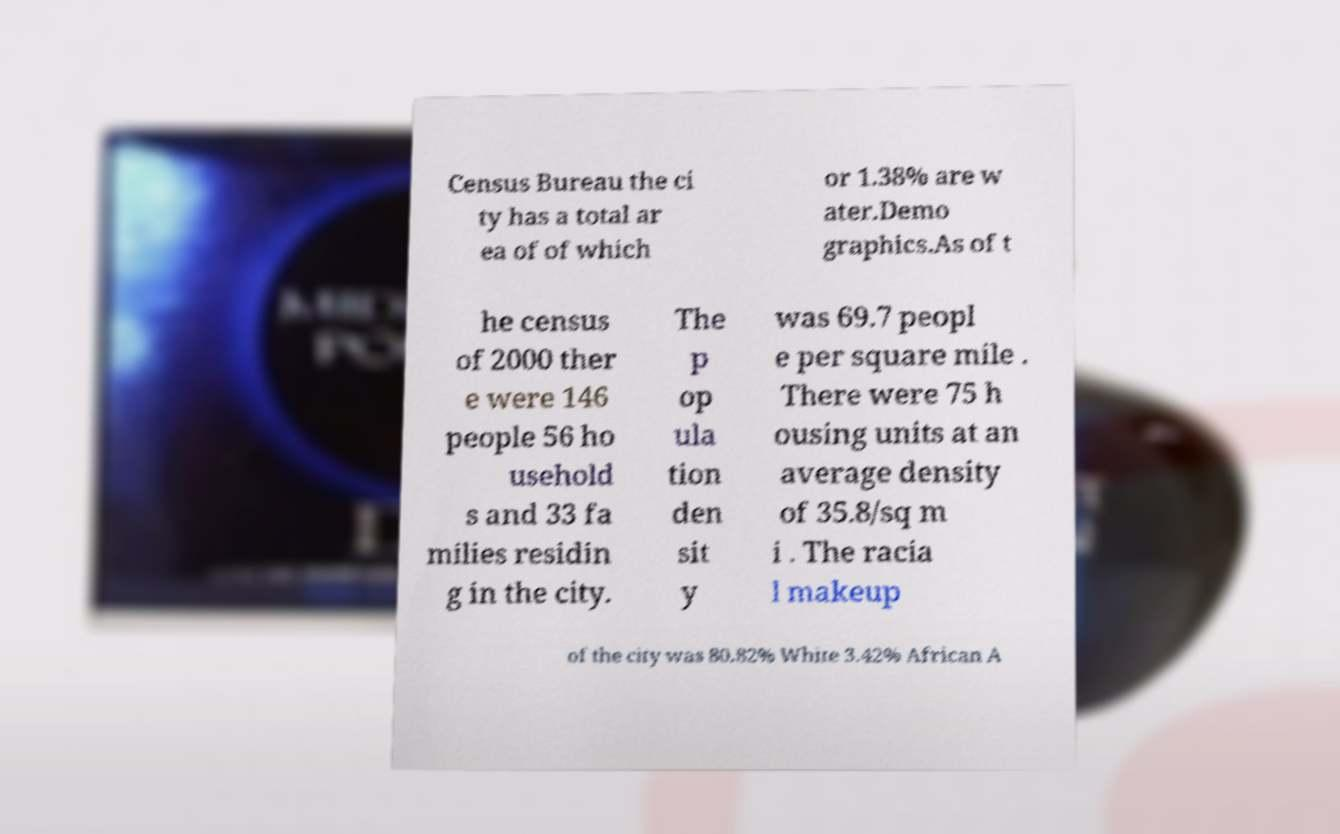Can you read and provide the text displayed in the image?This photo seems to have some interesting text. Can you extract and type it out for me? Census Bureau the ci ty has a total ar ea of of which or 1.38% are w ater.Demo graphics.As of t he census of 2000 ther e were 146 people 56 ho usehold s and 33 fa milies residin g in the city. The p op ula tion den sit y was 69.7 peopl e per square mile . There were 75 h ousing units at an average density of 35.8/sq m i . The racia l makeup of the city was 80.82% White 3.42% African A 